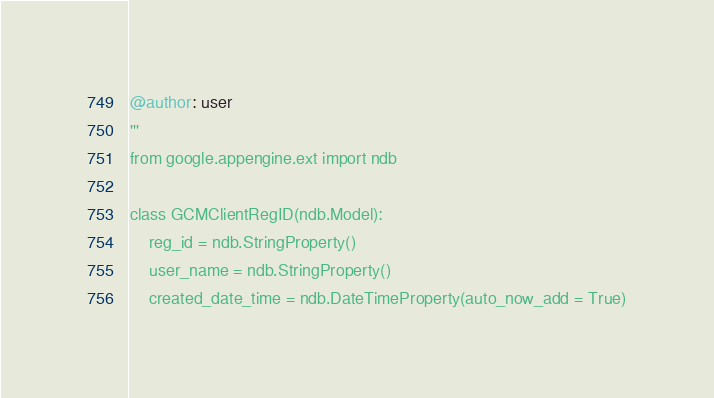Convert code to text. <code><loc_0><loc_0><loc_500><loc_500><_Python_>
@author: user
'''
from google.appengine.ext import ndb

class GCMClientRegID(ndb.Model):
    reg_id = ndb.StringProperty()
    user_name = ndb.StringProperty()
    created_date_time = ndb.DateTimeProperty(auto_now_add = True)</code> 